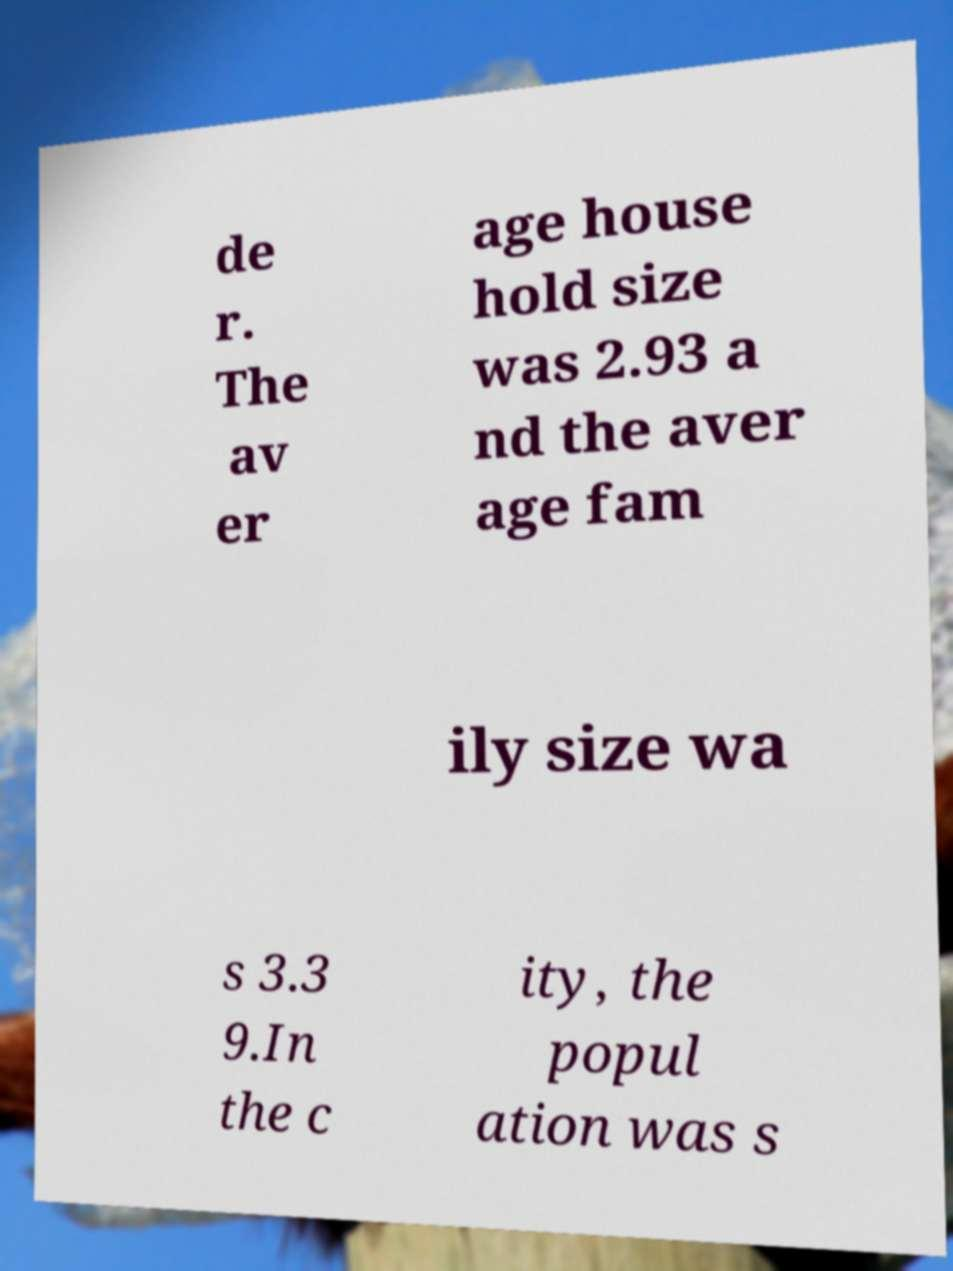Please read and relay the text visible in this image. What does it say? de r. The av er age house hold size was 2.93 a nd the aver age fam ily size wa s 3.3 9.In the c ity, the popul ation was s 